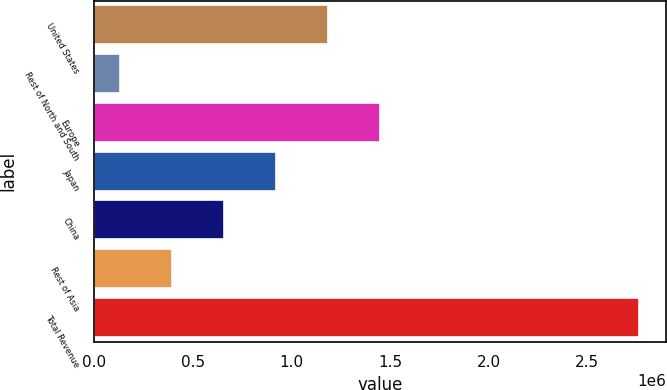Convert chart to OTSL. <chart><loc_0><loc_0><loc_500><loc_500><bar_chart><fcel>United States<fcel>Rest of North and South<fcel>Europe<fcel>Japan<fcel>China<fcel>Rest of Asia<fcel>Total Revenue<nl><fcel>1.1852e+06<fcel>134327<fcel>1.44792e+06<fcel>922480<fcel>659762<fcel>397045<fcel>2.7615e+06<nl></chart> 